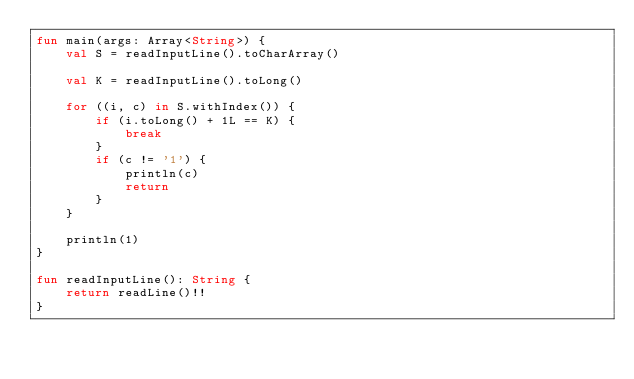<code> <loc_0><loc_0><loc_500><loc_500><_Kotlin_>fun main(args: Array<String>) {
    val S = readInputLine().toCharArray()
    
    val K = readInputLine().toLong()
    
    for ((i, c) in S.withIndex()) {
        if (i.toLong() + 1L == K) {
            break
        }
        if (c != '1') {
            println(c)
            return
        }
    }
    
    println(1)
}

fun readInputLine(): String {
    return readLine()!!
}
</code> 